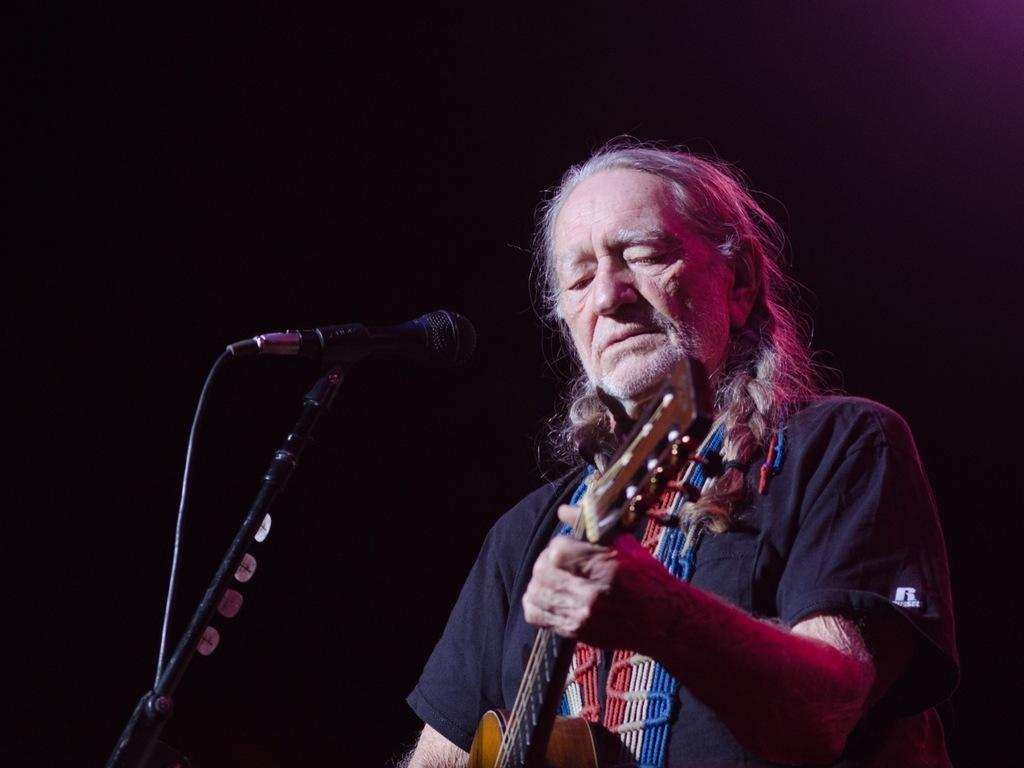What is the color of the background in the image? The background of the image is dark. Can you describe the person in the image? There is a man with long hair in the image. What is the man doing in the image? The man is standing in front of a microphone and playing a guitar. What type of quince is the man holding in the image? There is no quince present in the image; the man is playing a guitar and standing in front of a microphone. Can you tell me how the man's mother is reacting to his performance in the image? There is no information about the man's mother or her reaction in the image. 